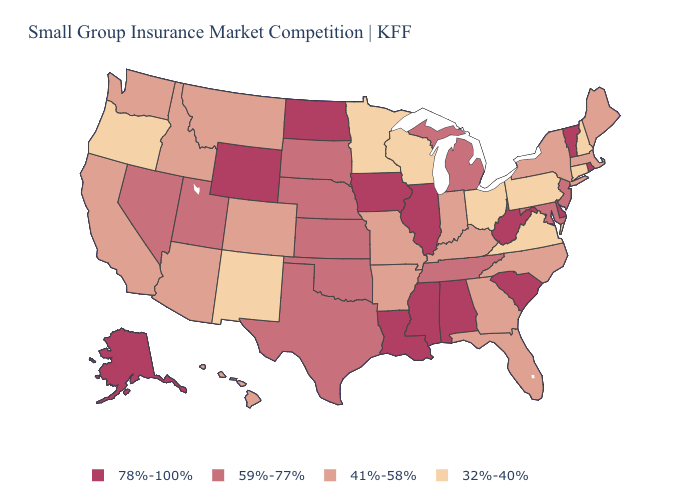Does the first symbol in the legend represent the smallest category?
Keep it brief. No. Which states hav the highest value in the Northeast?
Keep it brief. Rhode Island, Vermont. Among the states that border Montana , which have the lowest value?
Keep it brief. Idaho. Among the states that border Arkansas , which have the lowest value?
Quick response, please. Missouri. Which states have the lowest value in the South?
Write a very short answer. Virginia. Does Texas have the lowest value in the South?
Be succinct. No. Does Alabama have the highest value in the South?
Keep it brief. Yes. Does Missouri have the highest value in the USA?
Concise answer only. No. What is the lowest value in states that border Nevada?
Quick response, please. 32%-40%. How many symbols are there in the legend?
Keep it brief. 4. What is the highest value in states that border Delaware?
Concise answer only. 59%-77%. Does Georgia have a lower value than Mississippi?
Be succinct. Yes. Which states have the lowest value in the USA?
Give a very brief answer. Connecticut, Minnesota, New Hampshire, New Mexico, Ohio, Oregon, Pennsylvania, Virginia, Wisconsin. Does Illinois have a higher value than Iowa?
Give a very brief answer. No. What is the value of Oklahoma?
Give a very brief answer. 59%-77%. 